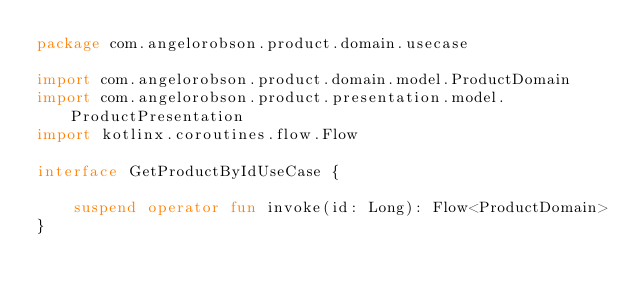<code> <loc_0><loc_0><loc_500><loc_500><_Kotlin_>package com.angelorobson.product.domain.usecase

import com.angelorobson.product.domain.model.ProductDomain
import com.angelorobson.product.presentation.model.ProductPresentation
import kotlinx.coroutines.flow.Flow

interface GetProductByIdUseCase {

    suspend operator fun invoke(id: Long): Flow<ProductDomain>
}</code> 